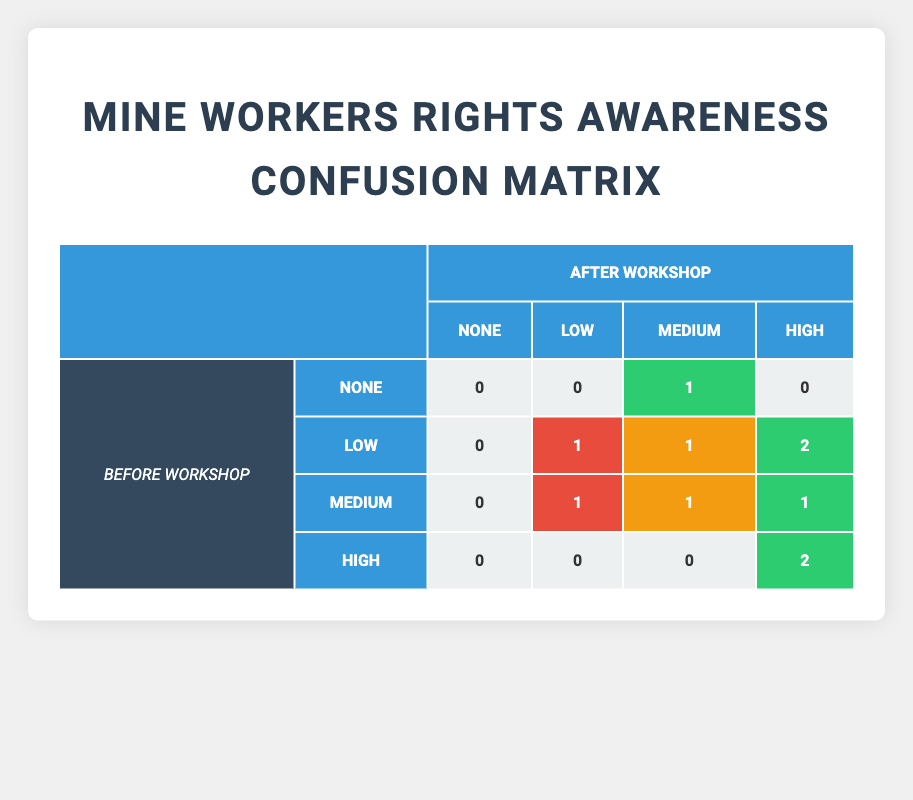What is the total number of workers who reported "High" awareness after the workshop? To find the total number of workers who reported "High" awareness after the workshop, we need to look at the relevant column for "After Workshop" under the "High" awareness category. There are a total of 5 workers who fall into this category.
Answer: 5 How many workers had "Low" awareness before the workshop? We need to sum the rows where the "Before Workshop" column is "Low." In the table, there are 3 workers who stated they had "Low" awareness before the workshop.
Answer: 3 Is it true that no workers reported "None" awareness after the workshop? We check the "None" category under the "After Workshop" row. The table has a count of 0 workers indicating that it is true that no workers reported "None" awareness after the workshop.
Answer: Yes What is the percentage of workers that improved their awareness level from "Low" to "High" after the workshop? To calculate the percentage, we first identify the workers who were "Low" before the workshop and "High" after the workshop. There are 2 workers who improved their awareness from "Low" to "High" out of a total of 3 workers who had "Low" awareness before. The percentage is (2/3) * 100 = 66.67%.
Answer: 66.67% How many workers decreased their awareness level from "Medium" before the workshop? We find workers who had "Medium" awareness before the workshop, and check their "After Workshop" awareness levels. One worker reported a decrease to "Low". Therefore, the total is one worker decreased their awareness level.
Answer: 1 What is the total count of workers who did not change their awareness level from before to after the workshop? We check the data for workers whose "Before Workshop" and "After Workshop" awareness levels are the same. The ones who remained "High" and "Medium" showed no change. There are a total of 4 workers with unchanged awareness levels.
Answer: 4 What is the difference in the number of workers reporting "Medium" awareness after the workshop compared to before? We compare the number of workers reporting "Medium" awareness before (3 workers) and after (2 workers). The difference is 3 - 2 = 1 worker.
Answer: 1 How many workers showed an increase in awareness levels from before to after the workshop? We examine all changes in awareness levels. Workers transitioning from "Low" to "High" or "Medium" to "High" indicate an improvement. There are a total of 4 workers who showed an increase in awareness.
Answer: 4 